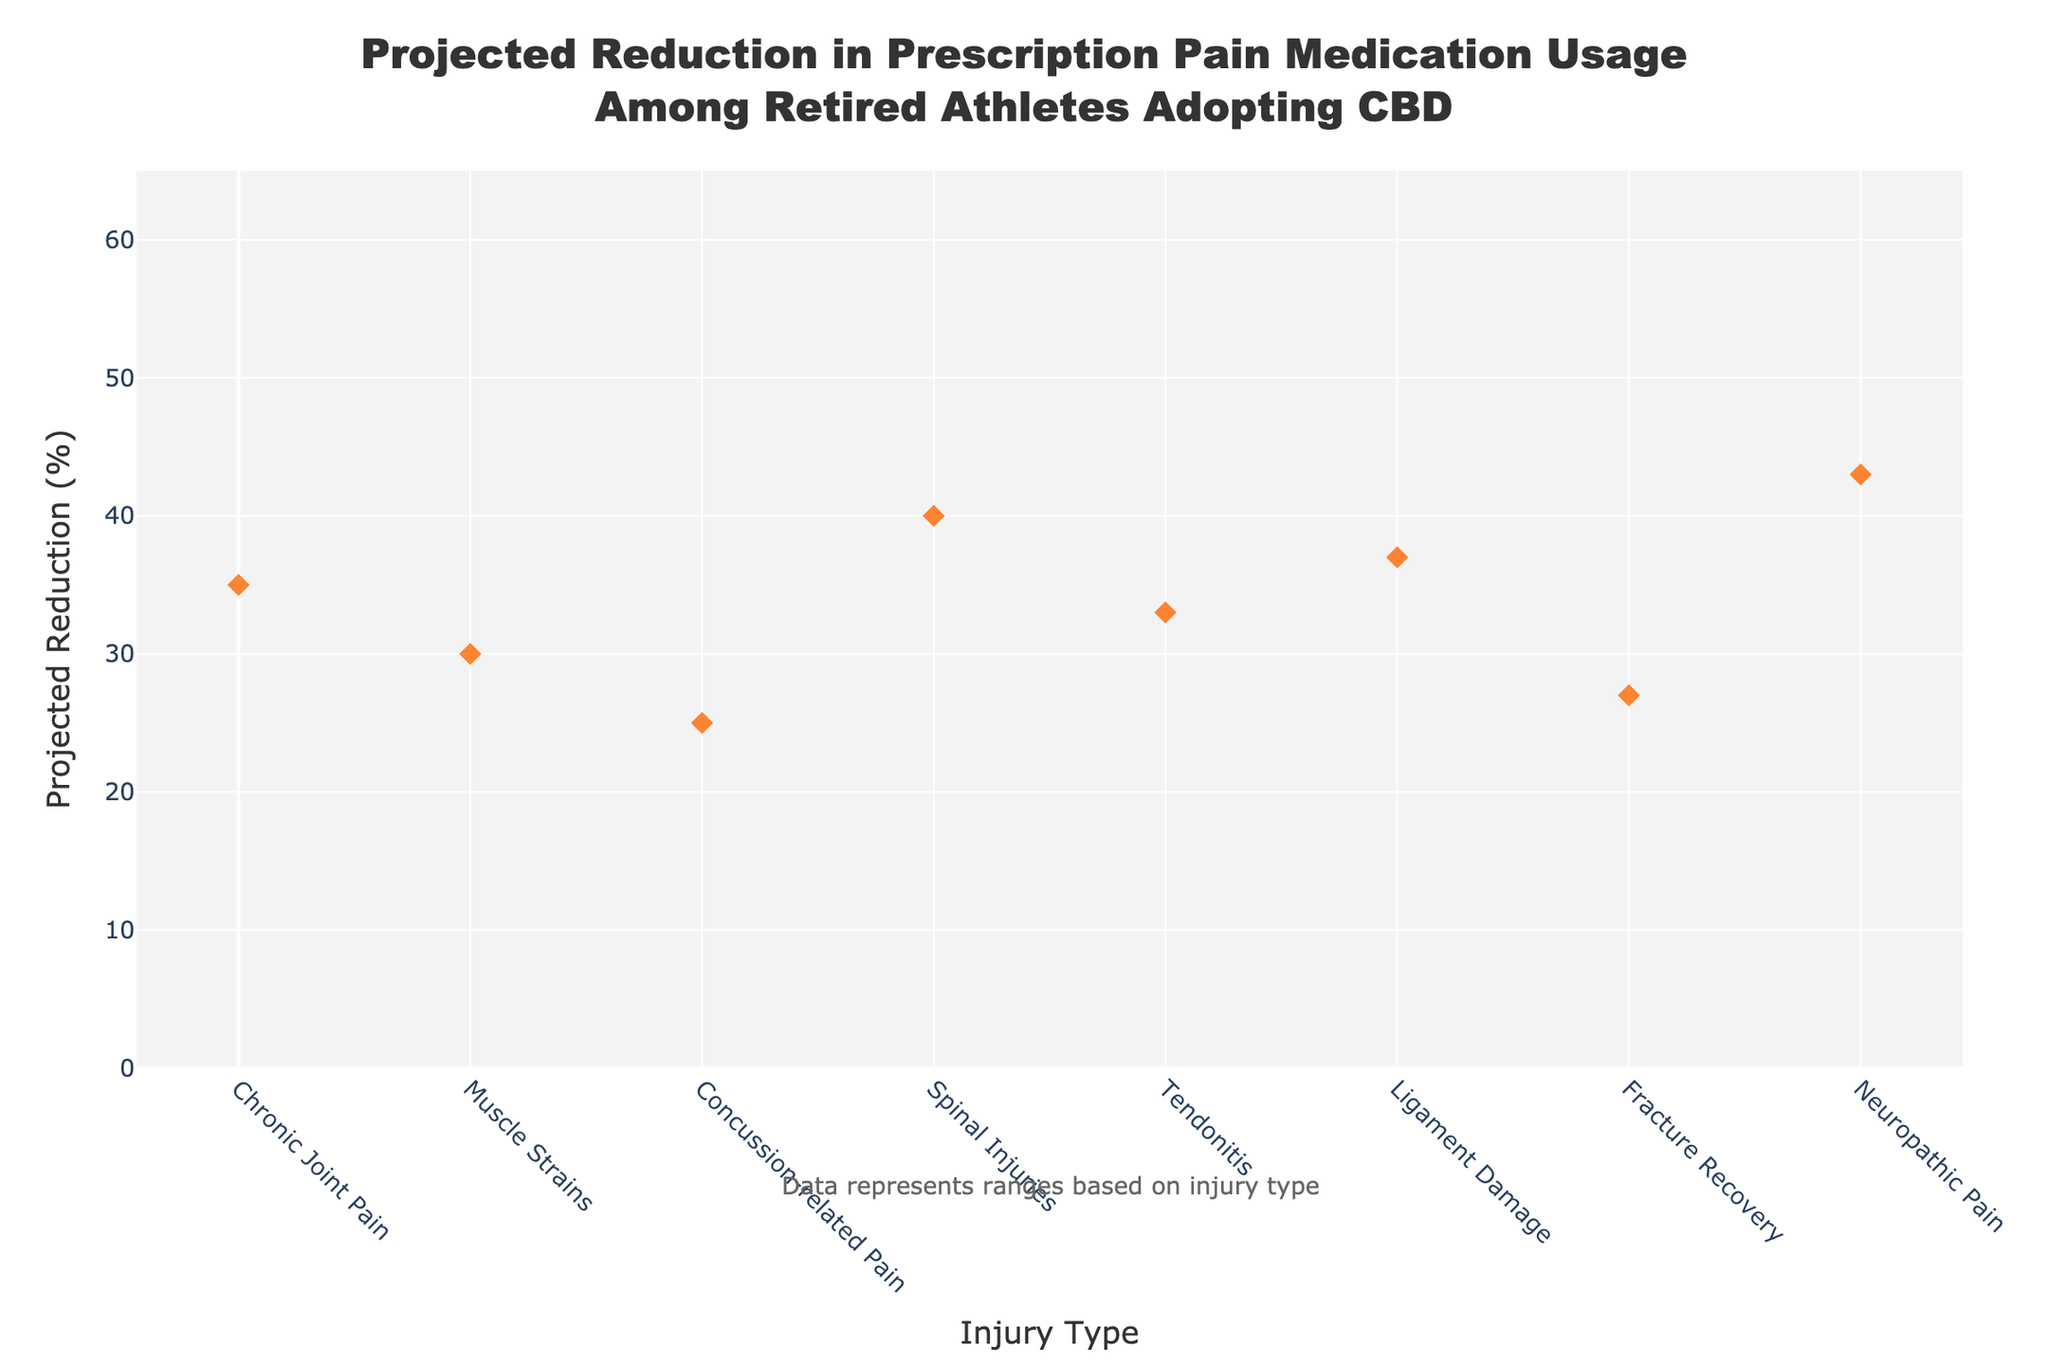What is the highest projected reduction range? The highest projected reduction range can be identified by looking for the highest percentage values on the y-axis. The highest range, spanning from the Low Estimate to the High Estimate, is for Neuropathic Pain, which ranges from 28% to 58%.
Answer: Neuropathic Pain (28% - 58%) Which injury type has the smallest projected reduction range? The smallest projected reduction range can be identified by finding the label with the lowest percentage values. For Concussion-related Pain, the reduction range spans from 10% to 40%.
Answer: Concussion-related Pain (10% - 40%) What is the most likely reduction percentage for Tendonitis? The most likely reduction for Tendonitis can be found by looking at the diamond marker associated with the Tendonitis label. The value next to the diamond on the y-axis is 33%.
Answer: 33% Which injury has the single highest most likely reduction percentage? The single highest most likely reduction is the highest value among all the diamond markers. Neuropathic Pain has the highest most likely reduction percentage at 43%.
Answer: Neuropathic Pain (43%) Compare the low estimate of Muscle Strains and Concussion-related Pain. Which is higher? To compare the low estimates, we look at the bottom of the filled areas for each injury type. Muscle Strains have a low estimate of 15% while Concussion-related Pain has a low estimate of 10%. Hence, Muscle Strains has a higher low estimate.
Answer: Muscle Strains What is the difference between the high estimates of Ligament Damage and Chronic Joint Pain? To find the difference, look for the high values on the y-axis for both Ligament Damage and Chronic Joint Pain. For Ligament Damage, the high estimate is 52% and for Chronic Joint Pain, it is 50%. The difference is 2%.
Answer: 2% Among the injuries listed, which has the smallest most likely reduction percentage? The smallest most likely reduction can be found by identifying the lowest diamond marker value. Concussion-related Pain has a most likely reduction of 25%, which is the smallest.
Answer: Concussion-related Pain (25%) What is the difference between the most likely and the high estimate for Fracture Recovery? For Fracture Recovery, the most likely reduction is 27% and the high estimate is 42%. The difference is calculated as 42% - 27%, which equals 15%.
Answer: 15% Which injury types have a most likely reduction percentage greater than 35%? Check the diamond markers and identify which ones are higher than 35%. Spinal Injuries (40%), Ligament Damage (37%), and Neuropathic Pain (43%) have most likely percentages greater than 35%.
Answer: Spinal Injuries, Ligament Damage, Neuropathic Pain 